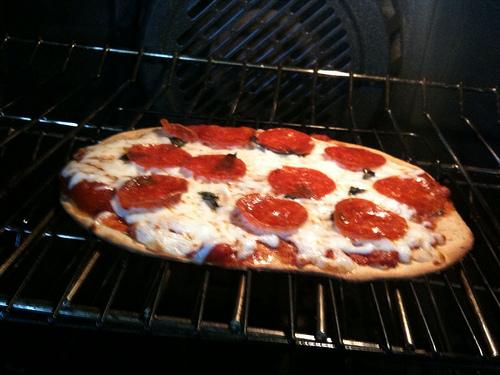In a casual style, describe what you notice in the image. There's this yummy thin-crust pepperoni pizza in the oven getting nice and hot, with melted cheese and some basil leaves making it irresistible. Write a child-friendly description of what you see in the image. Look at this yummy pepperoni pizza cooking in the oven! The cheese is all melty, and it even has some tasty basil leaves on top! I can't wait to try a slice! Explain the main elements of the image in a straightforward manner. The image shows a thin pepperoni pizza in an oven, placed on a black oven rack, with melted cheese and basil leaves on top. Provide a journalistic description of the image. In the photograph, a mouthwatering thin-crust pepperoni pizza cooks in an oven, exhibiting indications of culinary perfection with its splendidly melted cheese and inviting basil leaves. Describe the scene as if you were a cooking show host. And here, ladies and gentlemen, we have our delicious thin-crust pepperoni pizza, perfectly nestled inside our oven with golden melted cheese and aromatic basil leaves to enhance the flavors! Use a poetic style to describe the prominent aspects of the image. In a cozy oven, on a grate of black, lies a pepperoni pizza so thin, with cheese that's melted, and basil entwined, it's a symphony bringing delight. Provide a brief description of the primary components observed in the image. A thin pepperoni pizza is heating inside an oven, placed on a black oven rack, with melted cheese and cooked basil leaves on top. Describe the image as if you were a food critic. Our gaze is drawn to the alluring sight of a thin-crust pepperoni pizza, nestled within the oven, enticing our senses with pools of luxuriously melted cheese and cooked, fragrant basil leaves. Present the details of the image using a descriptive style. A delectable thin-crust pepperoni pizza, adorned with glorious pools of melted cheese and vibrant, cooked basil leaves, sits atop a black oven rack, cooking to perfection in a warm oven. 